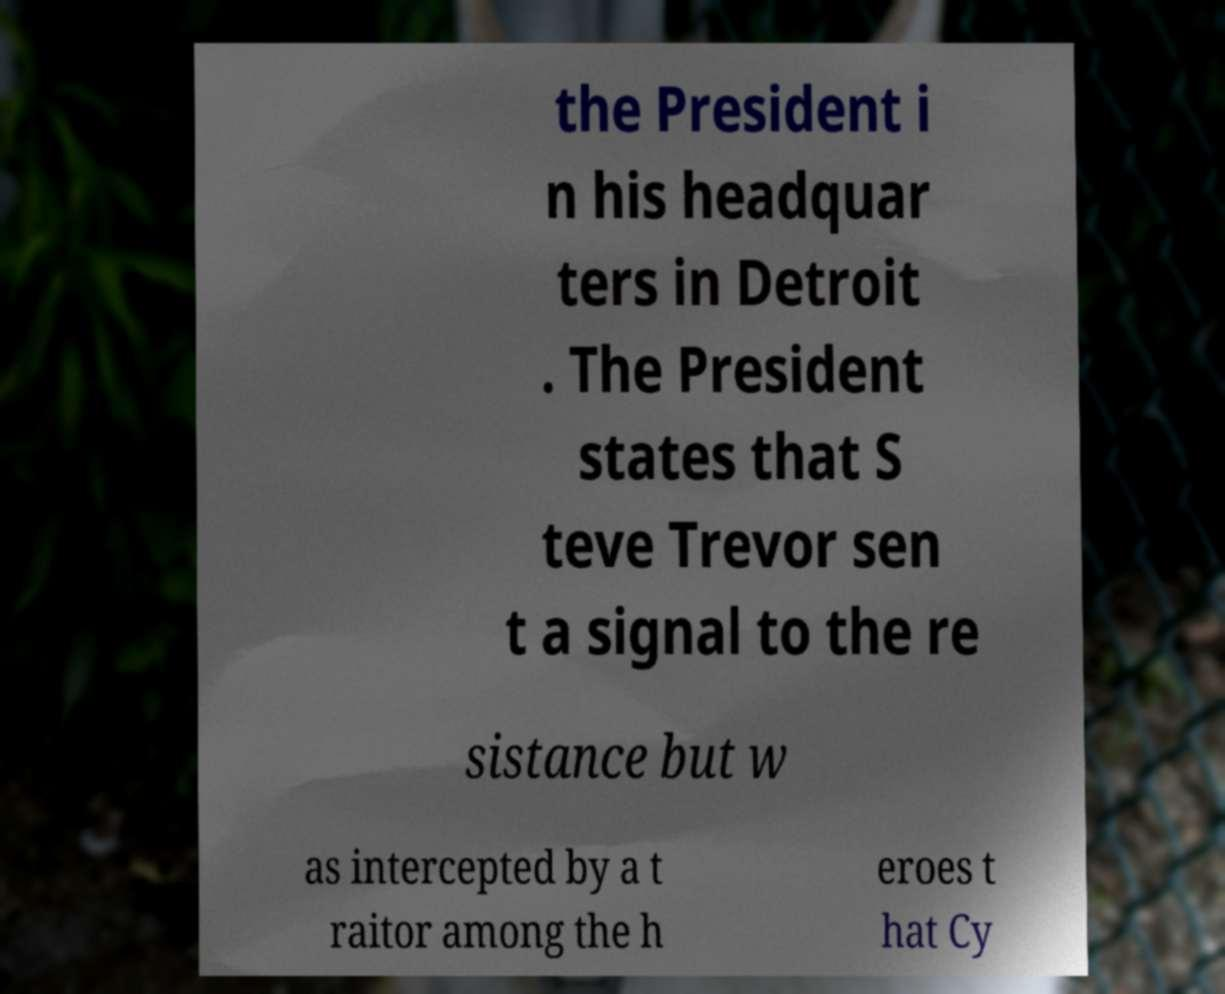Could you extract and type out the text from this image? the President i n his headquar ters in Detroit . The President states that S teve Trevor sen t a signal to the re sistance but w as intercepted by a t raitor among the h eroes t hat Cy 